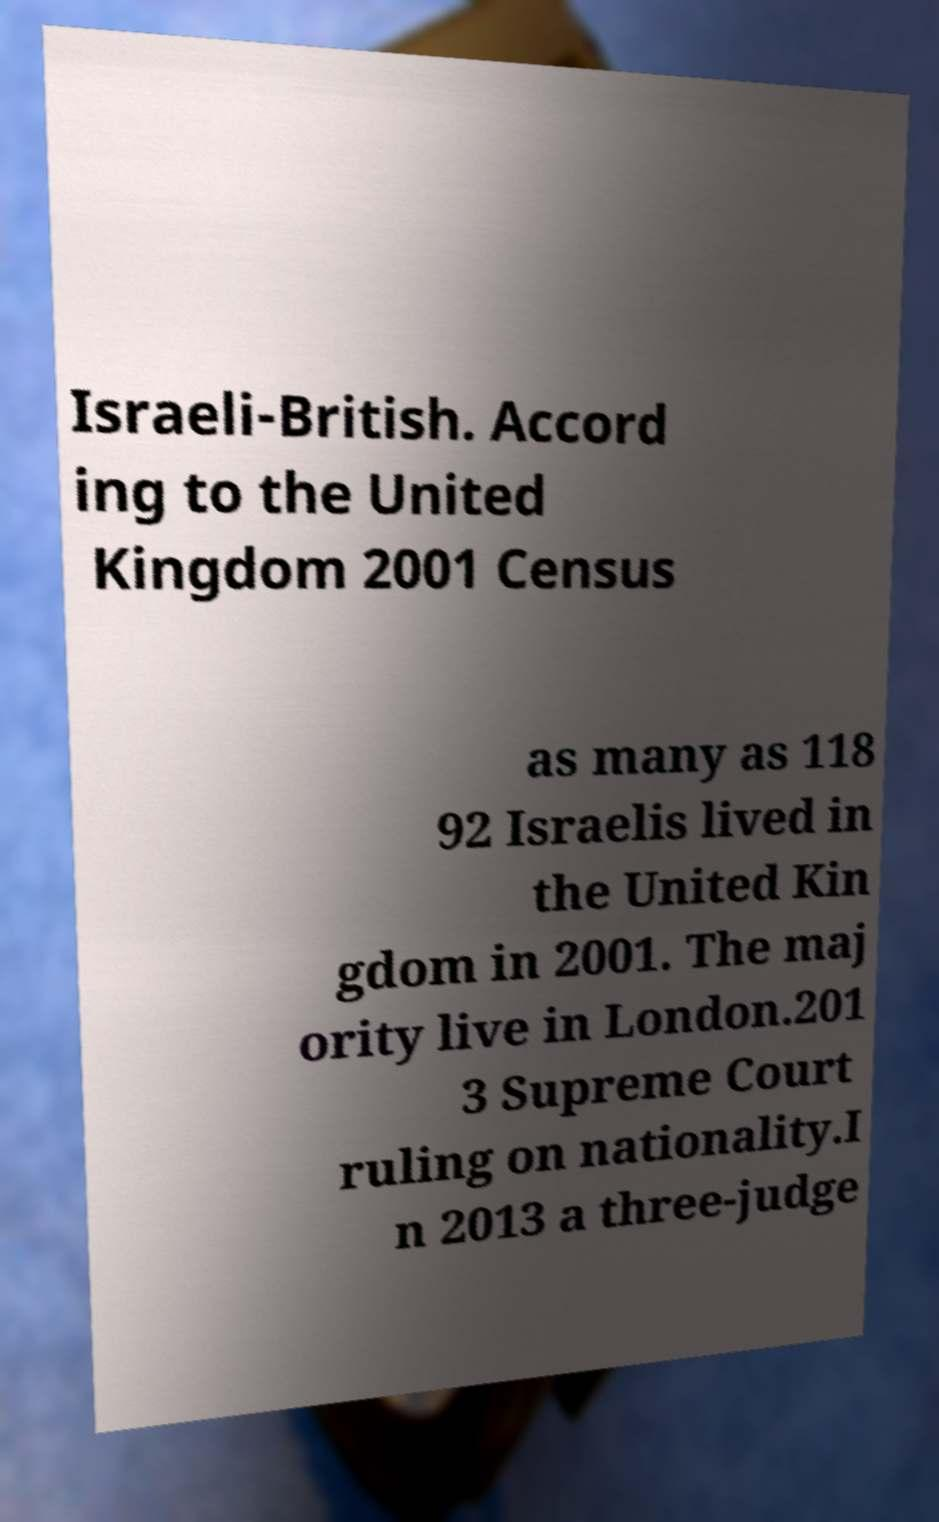Please read and relay the text visible in this image. What does it say? Israeli-British. Accord ing to the United Kingdom 2001 Census as many as 118 92 Israelis lived in the United Kin gdom in 2001. The maj ority live in London.201 3 Supreme Court ruling on nationality.I n 2013 a three-judge 